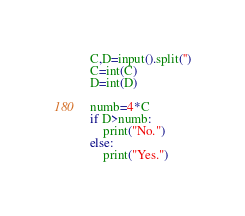Convert code to text. <code><loc_0><loc_0><loc_500><loc_500><_Python_>C,D=input().split('')
C=int(C)
D=int(D)

numb=4*C
if D>numb:
    print("No.")
else:
    print("Yes.")
</code> 